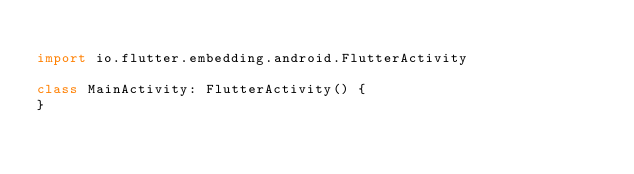<code> <loc_0><loc_0><loc_500><loc_500><_Kotlin_>
import io.flutter.embedding.android.FlutterActivity

class MainActivity: FlutterActivity() {
}
</code> 